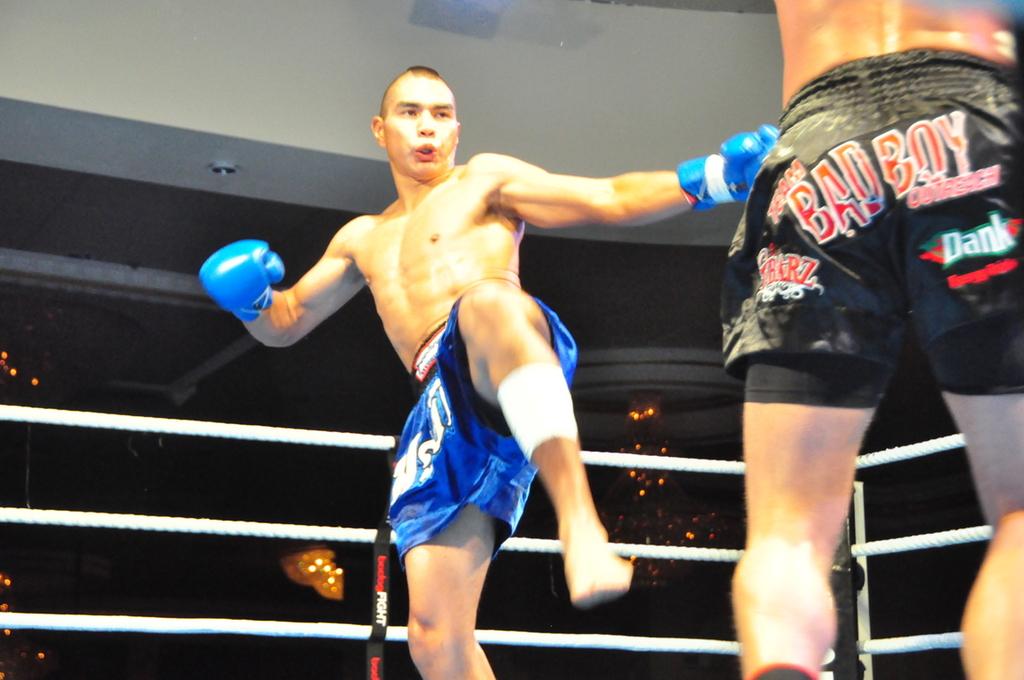What is the nickname of the boxer on the right?
Ensure brevity in your answer.  Bad boy. Is bad boy a sponsor of the black trunks fighter?
Keep it short and to the point. Yes. 